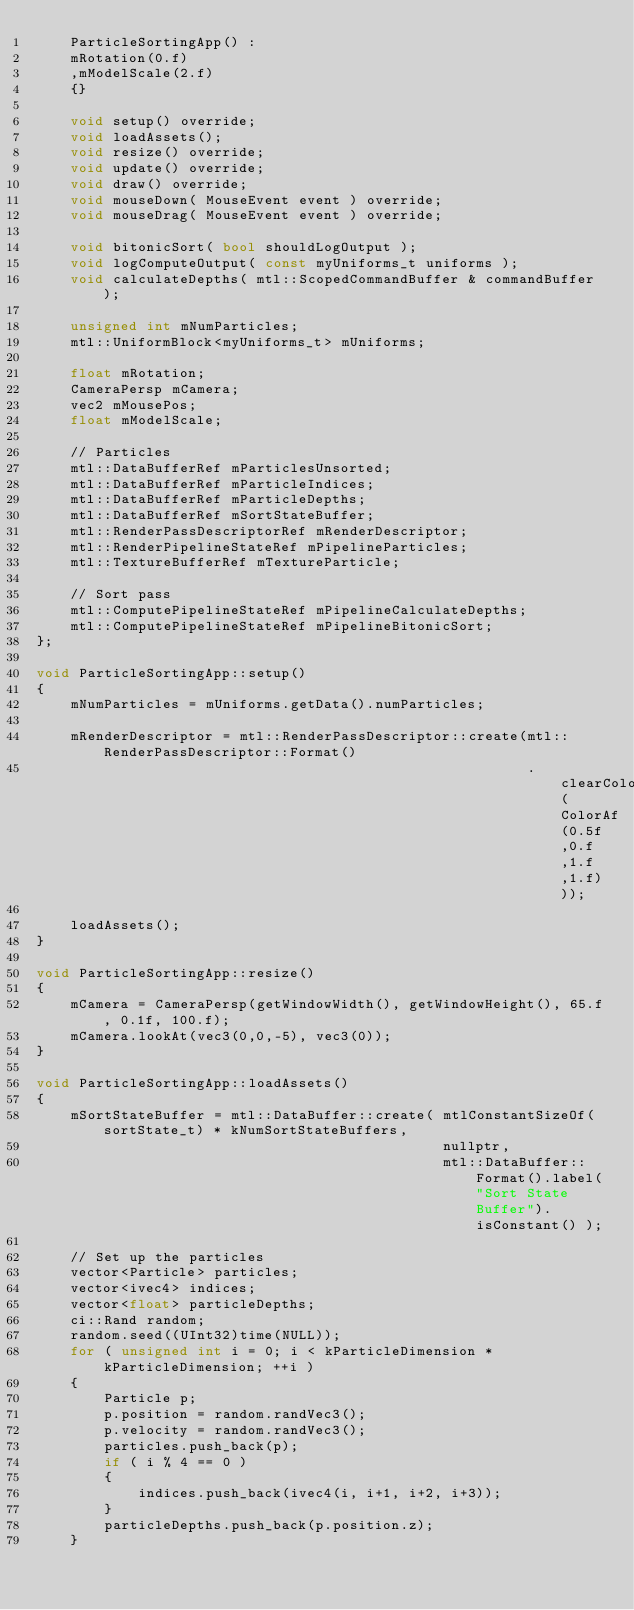Convert code to text. <code><loc_0><loc_0><loc_500><loc_500><_C++_>    ParticleSortingApp() :
    mRotation(0.f)
    ,mModelScale(2.f)
    {}
    
    void setup() override;
    void loadAssets();
    void resize() override;
    void update() override;
    void draw() override;
    void mouseDown( MouseEvent event ) override;
    void mouseDrag( MouseEvent event ) override;

    void bitonicSort( bool shouldLogOutput );
    void logComputeOutput( const myUniforms_t uniforms );
    void calculateDepths( mtl::ScopedCommandBuffer & commandBuffer );
    
    unsigned int mNumParticles;
    mtl::UniformBlock<myUniforms_t> mUniforms;

    float mRotation;
    CameraPersp mCamera;
    vec2 mMousePos;
    float mModelScale;

    // Particles
    mtl::DataBufferRef mParticlesUnsorted;
    mtl::DataBufferRef mParticleIndices;
    mtl::DataBufferRef mParticleDepths;
    mtl::DataBufferRef mSortStateBuffer;
    mtl::RenderPassDescriptorRef mRenderDescriptor;
    mtl::RenderPipelineStateRef mPipelineParticles;
    mtl::TextureBufferRef mTextureParticle;
    
    // Sort pass
    mtl::ComputePipelineStateRef mPipelineCalculateDepths;
    mtl::ComputePipelineStateRef mPipelineBitonicSort;
};

void ParticleSortingApp::setup()
{
    mNumParticles = mUniforms.getData().numParticles;
    
    mRenderDescriptor = mtl::RenderPassDescriptor::create(mtl::RenderPassDescriptor::Format()
                                                          .clearColor( ColorAf(0.5f,0.f,1.f,1.f)));

    loadAssets();
}

void ParticleSortingApp::resize()
{
    mCamera = CameraPersp(getWindowWidth(), getWindowHeight(), 65.f, 0.1f, 100.f);
    mCamera.lookAt(vec3(0,0,-5), vec3(0));
}

void ParticleSortingApp::loadAssets()
{
    mSortStateBuffer = mtl::DataBuffer::create( mtlConstantSizeOf(sortState_t) * kNumSortStateBuffers,
                                                nullptr,
                                                mtl::DataBuffer::Format().label("Sort State Buffer").isConstant() );

    // Set up the particles
    vector<Particle> particles;
    vector<ivec4> indices;
    vector<float> particleDepths;
    ci::Rand random;
    random.seed((UInt32)time(NULL));
    for ( unsigned int i = 0; i < kParticleDimension * kParticleDimension; ++i )
    {
        Particle p;
        p.position = random.randVec3();
        p.velocity = random.randVec3();
        particles.push_back(p);
        if ( i % 4 == 0 )
        {
            indices.push_back(ivec4(i, i+1, i+2, i+3));
        }
        particleDepths.push_back(p.position.z);
    }
</code> 